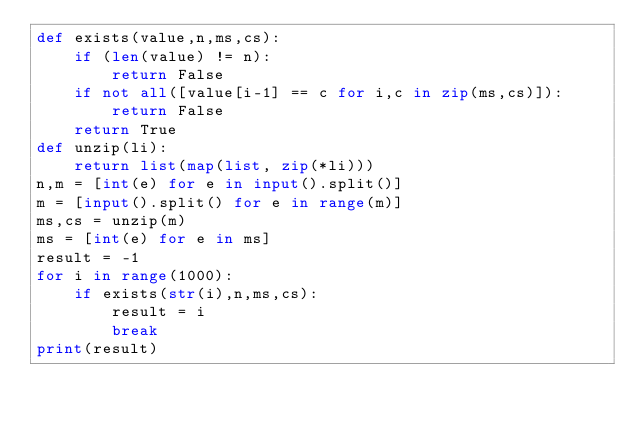Convert code to text. <code><loc_0><loc_0><loc_500><loc_500><_Python_>def exists(value,n,ms,cs):
    if (len(value) != n):
        return False
    if not all([value[i-1] == c for i,c in zip(ms,cs)]):
        return False
    return True
def unzip(li):
    return list(map(list, zip(*li)))
n,m = [int(e) for e in input().split()]
m = [input().split() for e in range(m)]
ms,cs = unzip(m)
ms = [int(e) for e in ms]
result = -1
for i in range(1000):
    if exists(str(i),n,ms,cs):
        result = i
        break
print(result)</code> 